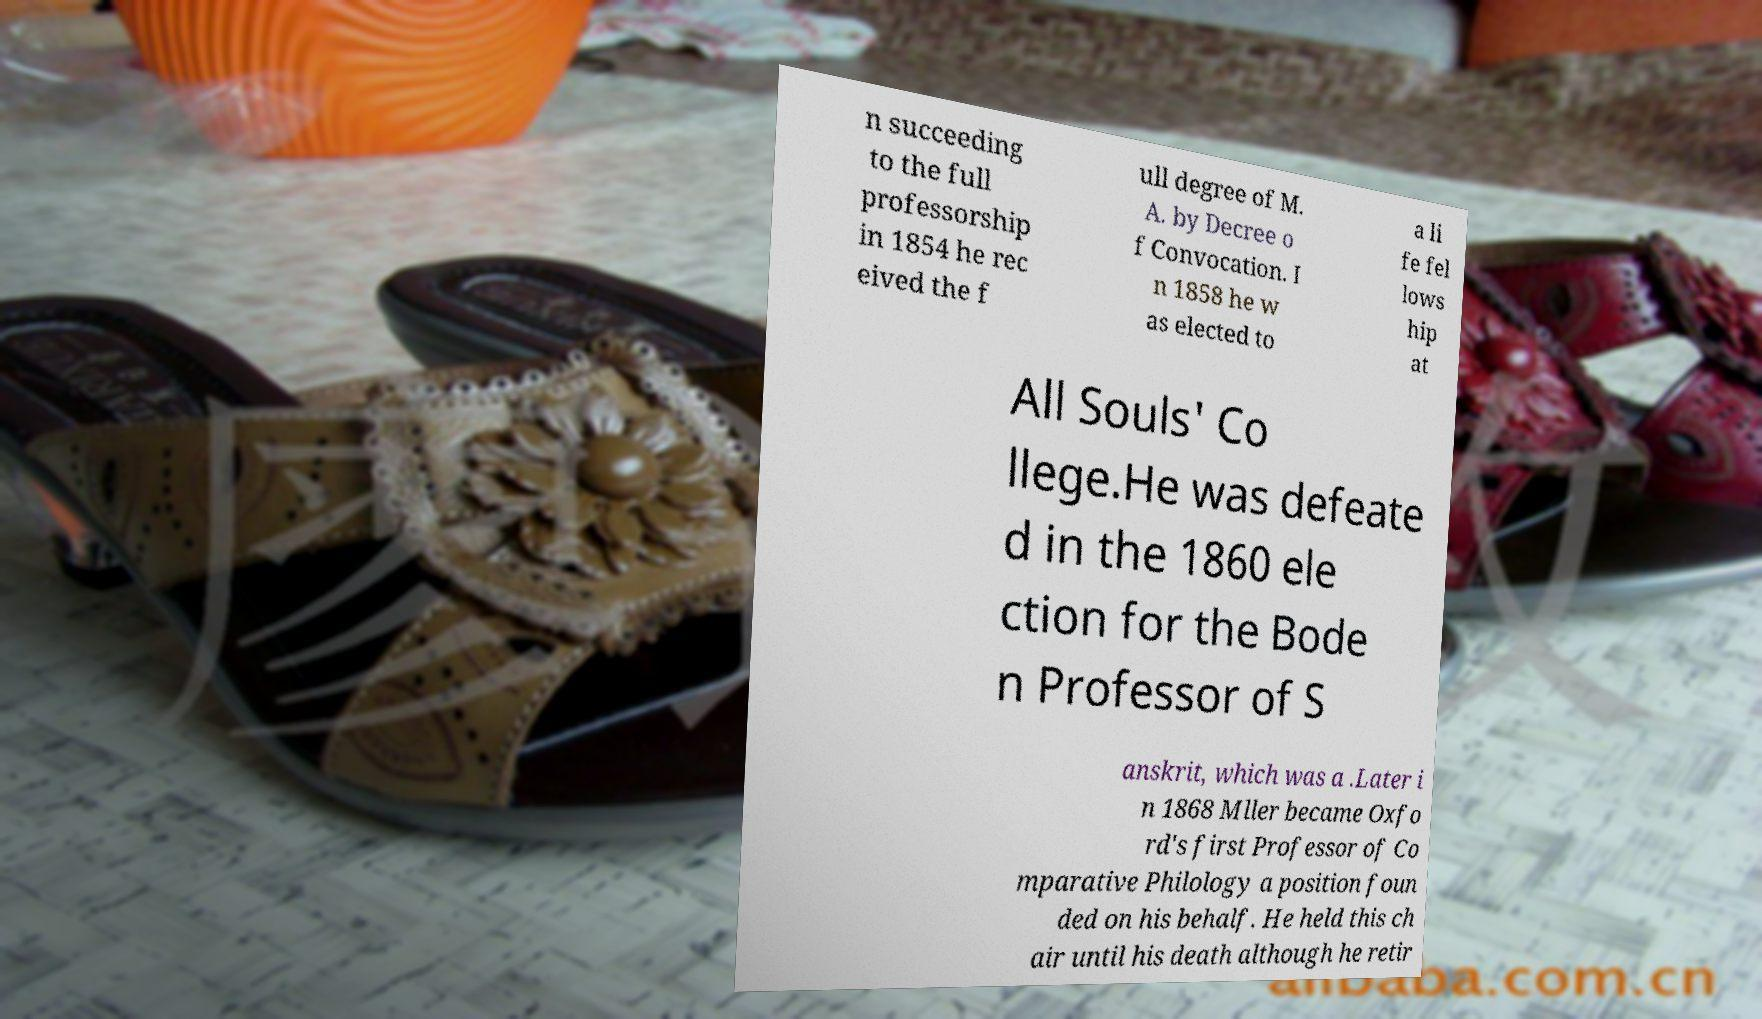Please identify and transcribe the text found in this image. n succeeding to the full professorship in 1854 he rec eived the f ull degree of M. A. by Decree o f Convocation. I n 1858 he w as elected to a li fe fel lows hip at All Souls' Co llege.He was defeate d in the 1860 ele ction for the Bode n Professor of S anskrit, which was a .Later i n 1868 Mller became Oxfo rd's first Professor of Co mparative Philology a position foun ded on his behalf. He held this ch air until his death although he retir 